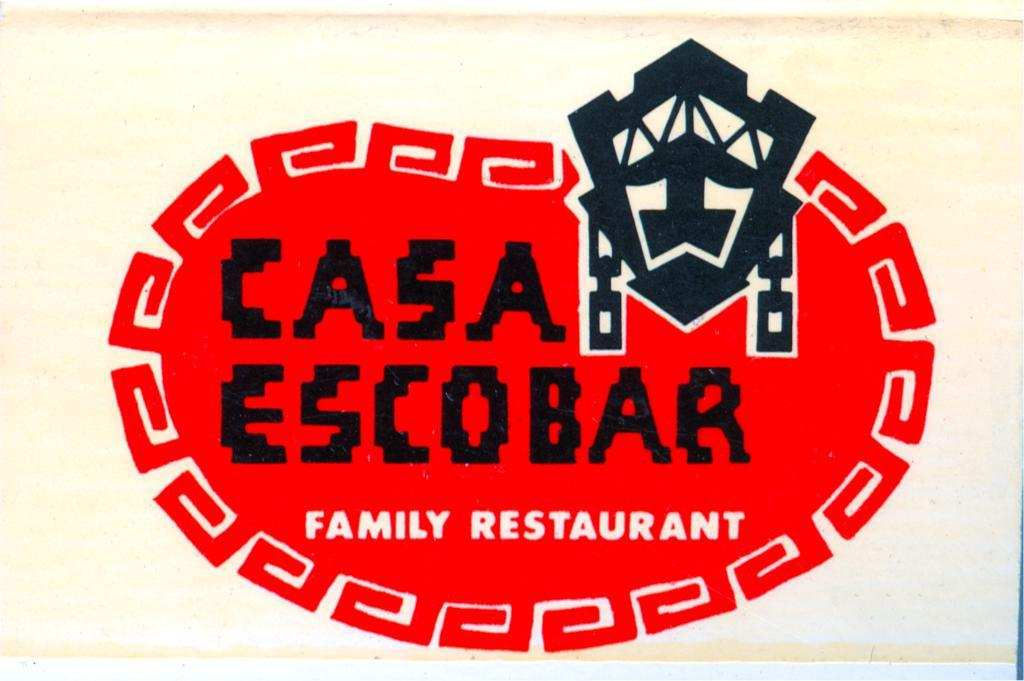<image>
Summarize the visual content of the image. A logo for Casa Escobar Family Restaurant in orange and black. 